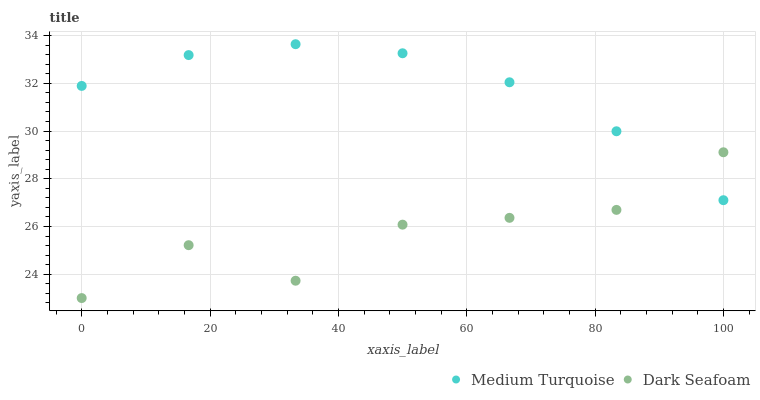Does Dark Seafoam have the minimum area under the curve?
Answer yes or no. Yes. Does Medium Turquoise have the maximum area under the curve?
Answer yes or no. Yes. Does Medium Turquoise have the minimum area under the curve?
Answer yes or no. No. Is Medium Turquoise the smoothest?
Answer yes or no. Yes. Is Dark Seafoam the roughest?
Answer yes or no. Yes. Is Medium Turquoise the roughest?
Answer yes or no. No. Does Dark Seafoam have the lowest value?
Answer yes or no. Yes. Does Medium Turquoise have the lowest value?
Answer yes or no. No. Does Medium Turquoise have the highest value?
Answer yes or no. Yes. Does Medium Turquoise intersect Dark Seafoam?
Answer yes or no. Yes. Is Medium Turquoise less than Dark Seafoam?
Answer yes or no. No. Is Medium Turquoise greater than Dark Seafoam?
Answer yes or no. No. 